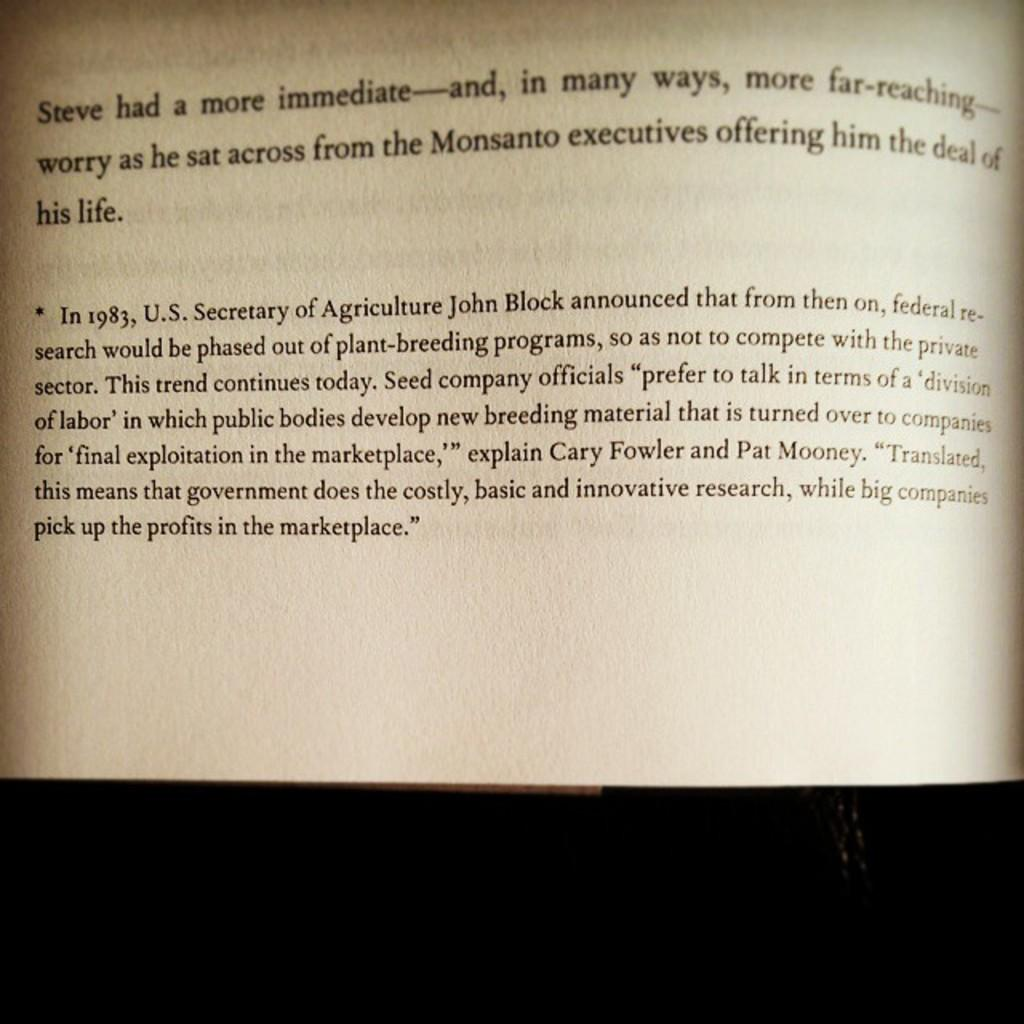<image>
Relay a brief, clear account of the picture shown. A book is open to a page that begins with the word Steve. 